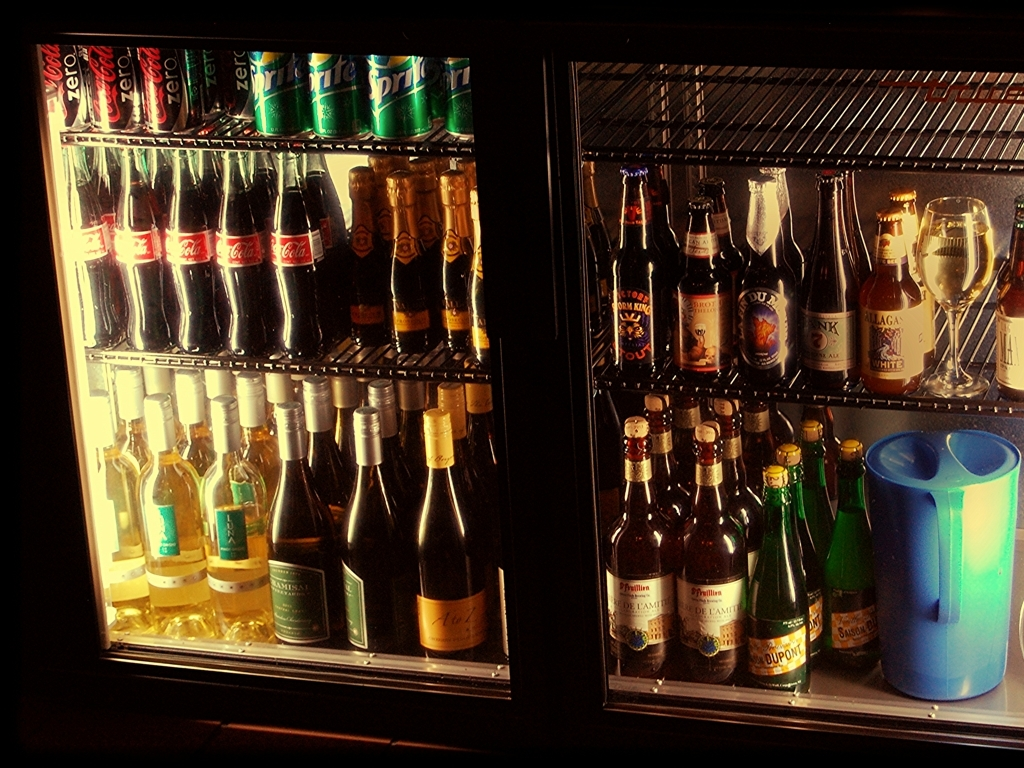What can you deduce about the lighting conditions in the image? The lighting appears to be artificial, perhaps from the appliance's own illumination, emphasizing the bottles' labels and the liquid's colors. The surrounding area outside the refrigerator is dim, suggesting a low-light environment, which is typical in bars or evening settings. Does the image indicate if any of the bottles have been opened or used? All the bottles and cans appear to be sealed and intact, with no visible signs of opening or consumption. This could imply that the image was taken before the beverages were offered for sale or served to customers. 